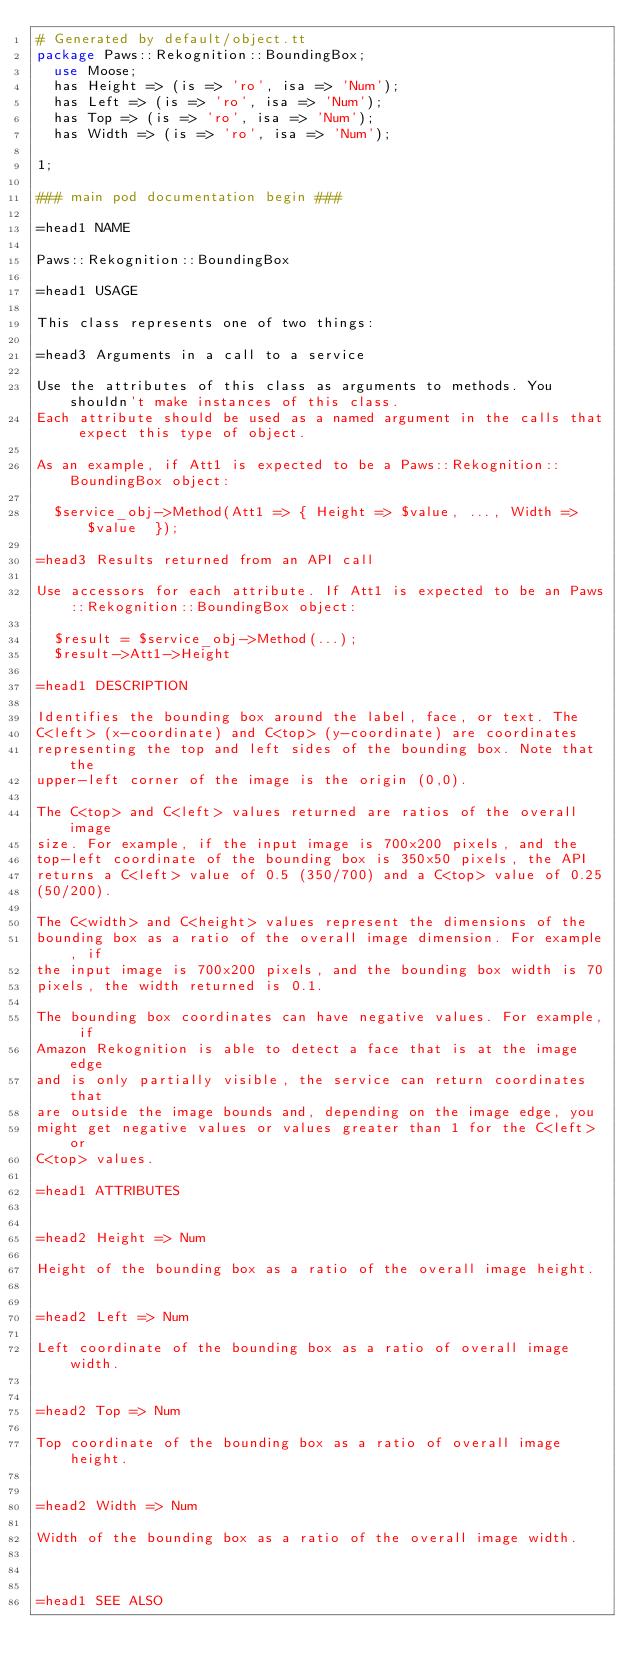<code> <loc_0><loc_0><loc_500><loc_500><_Perl_># Generated by default/object.tt
package Paws::Rekognition::BoundingBox;
  use Moose;
  has Height => (is => 'ro', isa => 'Num');
  has Left => (is => 'ro', isa => 'Num');
  has Top => (is => 'ro', isa => 'Num');
  has Width => (is => 'ro', isa => 'Num');

1;

### main pod documentation begin ###

=head1 NAME

Paws::Rekognition::BoundingBox

=head1 USAGE

This class represents one of two things:

=head3 Arguments in a call to a service

Use the attributes of this class as arguments to methods. You shouldn't make instances of this class. 
Each attribute should be used as a named argument in the calls that expect this type of object.

As an example, if Att1 is expected to be a Paws::Rekognition::BoundingBox object:

  $service_obj->Method(Att1 => { Height => $value, ..., Width => $value  });

=head3 Results returned from an API call

Use accessors for each attribute. If Att1 is expected to be an Paws::Rekognition::BoundingBox object:

  $result = $service_obj->Method(...);
  $result->Att1->Height

=head1 DESCRIPTION

Identifies the bounding box around the label, face, or text. The
C<left> (x-coordinate) and C<top> (y-coordinate) are coordinates
representing the top and left sides of the bounding box. Note that the
upper-left corner of the image is the origin (0,0).

The C<top> and C<left> values returned are ratios of the overall image
size. For example, if the input image is 700x200 pixels, and the
top-left coordinate of the bounding box is 350x50 pixels, the API
returns a C<left> value of 0.5 (350/700) and a C<top> value of 0.25
(50/200).

The C<width> and C<height> values represent the dimensions of the
bounding box as a ratio of the overall image dimension. For example, if
the input image is 700x200 pixels, and the bounding box width is 70
pixels, the width returned is 0.1.

The bounding box coordinates can have negative values. For example, if
Amazon Rekognition is able to detect a face that is at the image edge
and is only partially visible, the service can return coordinates that
are outside the image bounds and, depending on the image edge, you
might get negative values or values greater than 1 for the C<left> or
C<top> values.

=head1 ATTRIBUTES


=head2 Height => Num

Height of the bounding box as a ratio of the overall image height.


=head2 Left => Num

Left coordinate of the bounding box as a ratio of overall image width.


=head2 Top => Num

Top coordinate of the bounding box as a ratio of overall image height.


=head2 Width => Num

Width of the bounding box as a ratio of the overall image width.



=head1 SEE ALSO
</code> 